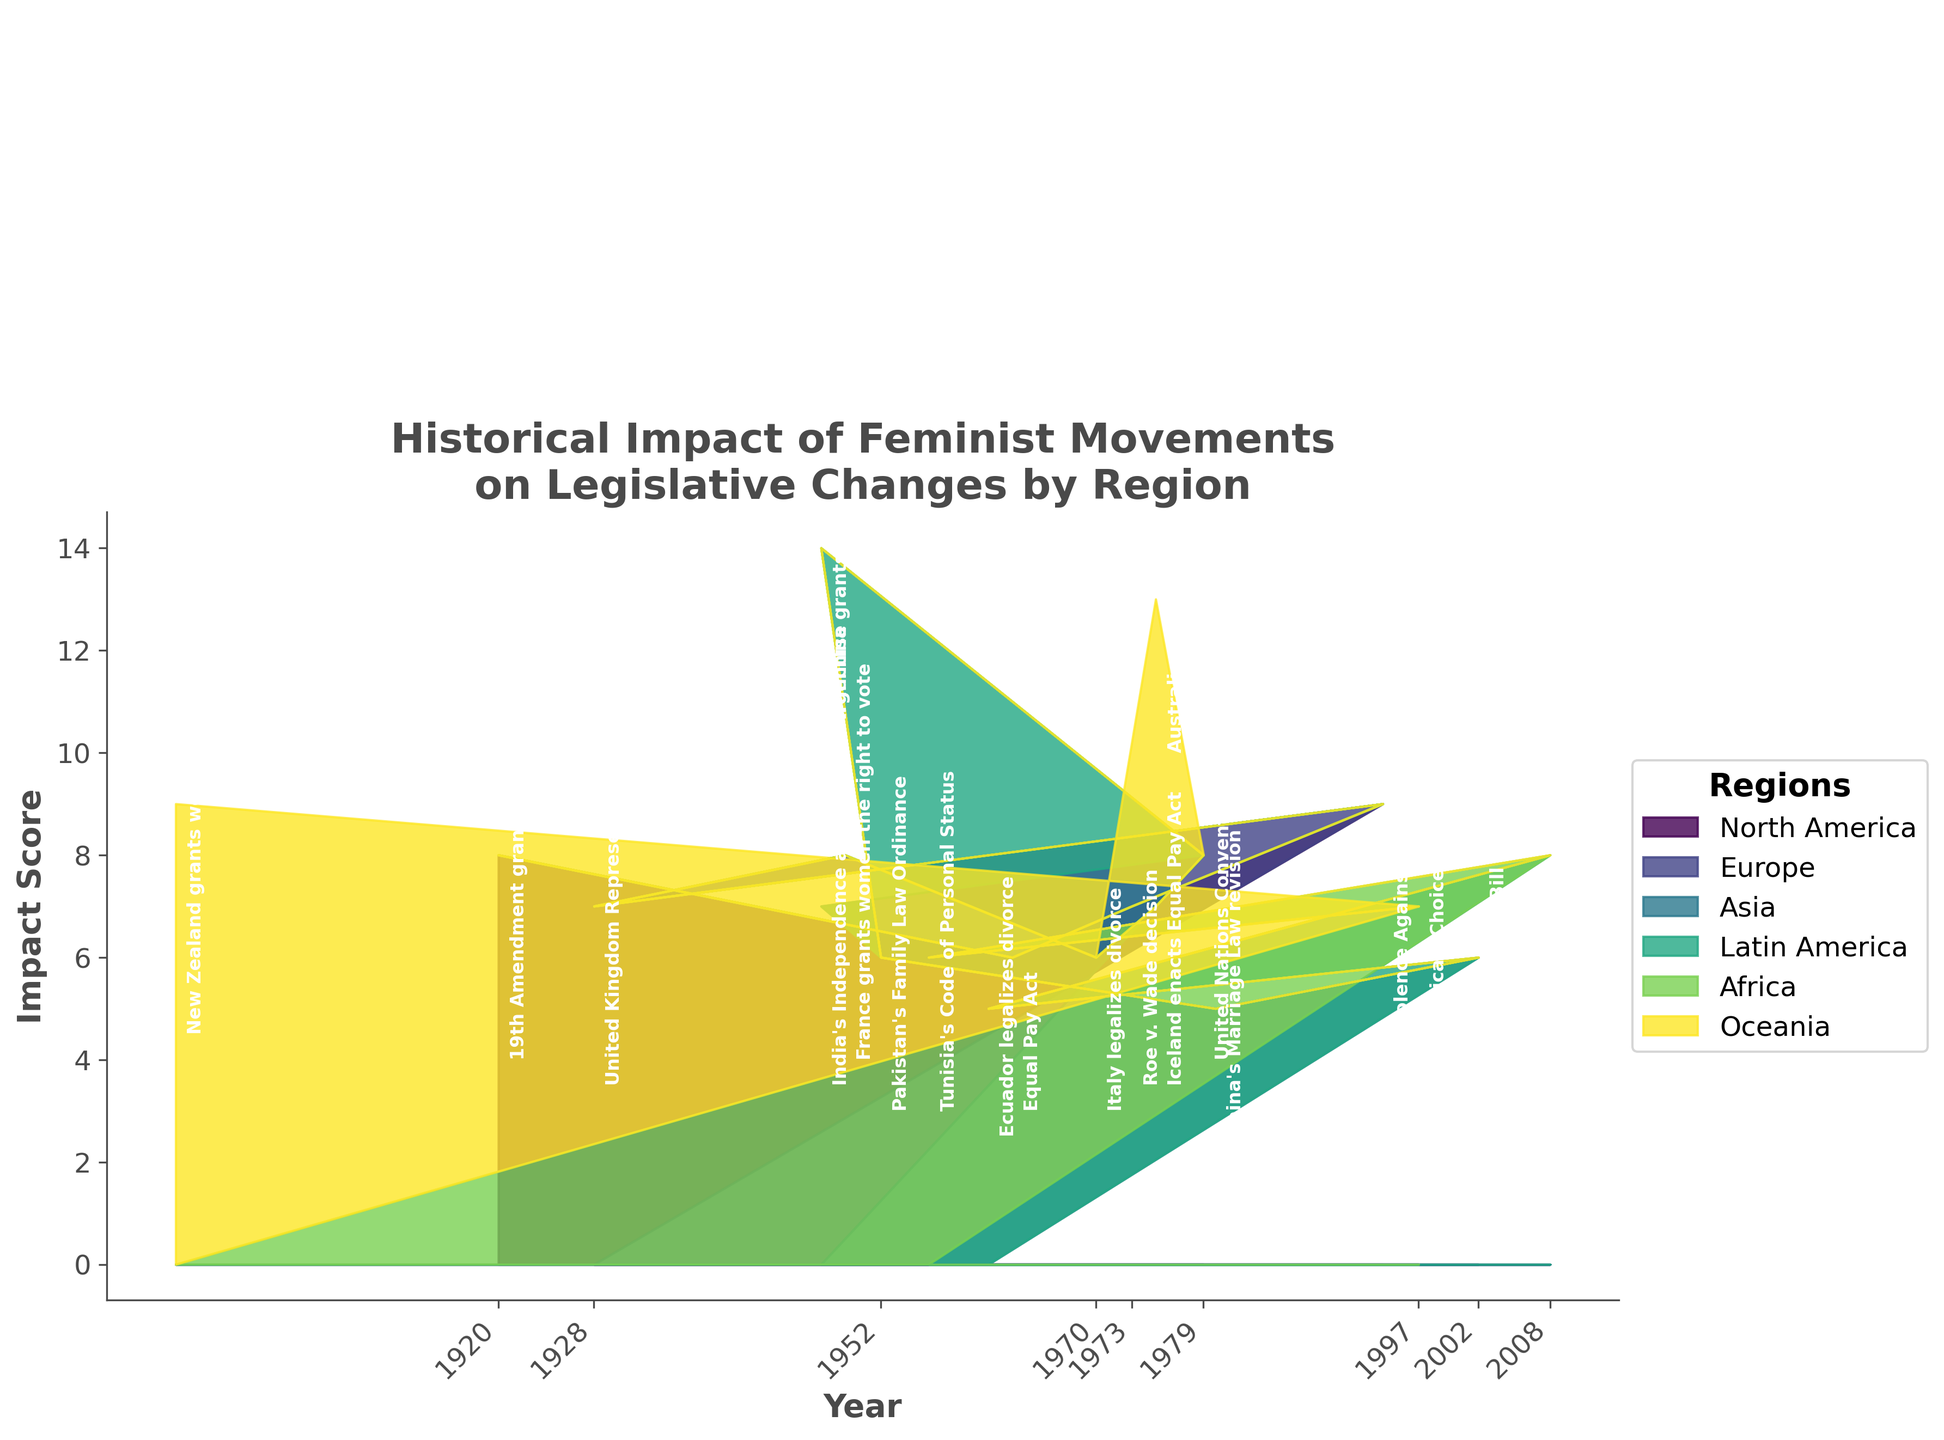What is the title of the figure? The title is displayed at the top of the figure as "Historical Impact of Feminist Movements on Legislative Changes by Region," formatted in bold and larger font size than other text.
Answer: Historical Impact of Feminist Movements on Legislative Changes by Region What are the labels on the axes? The x-axis is labeled "Year," and the y-axis is labeled "Impact Score." These labels are shown in bold font.
Answer: Year, Impact Score Which region has the first significant legislative change according to the plot? Oceania is the first region with significant legislative change, visible by the early section of the stream graph starting in 1893.
Answer: Oceania Which regions have legislative changes with an impact score of 9? In the plot, you can see high peaks labeled with an impact score of 9 for North America (1994) and Oceania (1893).
Answer: North America, Oceania How does the legislative impact score in North America compare between 1920 and 1994? In 1920, the impact score for North America is 8; in 1994, the score is 9. Thus, the score increased by 1 over these years.
Answer: Increased by 1 What similarities can you find between the impact scores of legislative changes in Europe and Asia? Both Europe and Asia have consistent peaks in the plot indicating legislative changes with moderate impact scores (5-8), showing a spread of changes across years.
Answer: Consistent moderate scores Which legislative change in Europe has the highest impact score, and when did it happen? The highest impact score in Europe is 8, seen for France granting women the right to vote in 1949 and the UN CEDAW in 1979. These peaks are labeled on the stream graph.
Answer: France grants women the right to vote (1949) and UN CEDAW (1979) Between 1940 and 1950, which region shows the highest legislative impact score and what is the value? Between these years, Europe has the highest impact score, reaching 8, indicated by France granting women the right to vote in 1949.
Answer: Europe (8) What patterns can you observe in the legislative changes' impact scores for Latin America? The impact scores in Latin America show spikes around 1947, 1961, and 2008, corresponding to Argentina granting women’s suffrage, Ecuador legalizing divorce, and Brazil’s Domestic Violence Law, respectively. This is visible through different height peaks on the stream graph.
Answer: Spikes in 1947, 1961, and 2008 